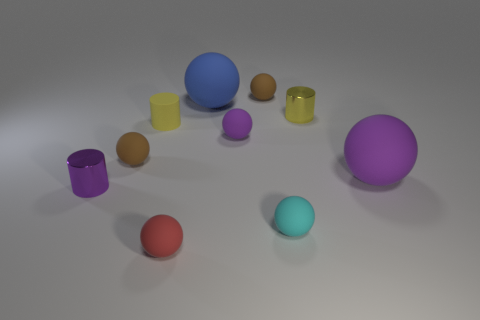What number of blocks are either purple metal objects or tiny purple matte objects?
Provide a short and direct response. 0. There is a purple metal object that is the same shape as the yellow matte object; what is its size?
Your response must be concise. Small. What number of small yellow cylinders are there?
Offer a terse response. 2. Does the big blue rubber thing have the same shape as the yellow object to the right of the small purple rubber ball?
Provide a succinct answer. No. There is a purple ball that is to the right of the small yellow metallic thing; what is its size?
Your answer should be very brief. Large. What material is the purple cylinder?
Your answer should be compact. Metal. Is the shape of the small yellow object right of the small red object the same as  the big blue matte thing?
Your answer should be compact. No. The metallic thing that is the same color as the tiny matte cylinder is what size?
Your response must be concise. Small. Are there any yellow matte objects of the same size as the purple cylinder?
Offer a terse response. Yes. Are there any brown rubber objects that are in front of the tiny matte thing that is behind the small metallic cylinder to the right of the purple metallic object?
Keep it short and to the point. Yes. 